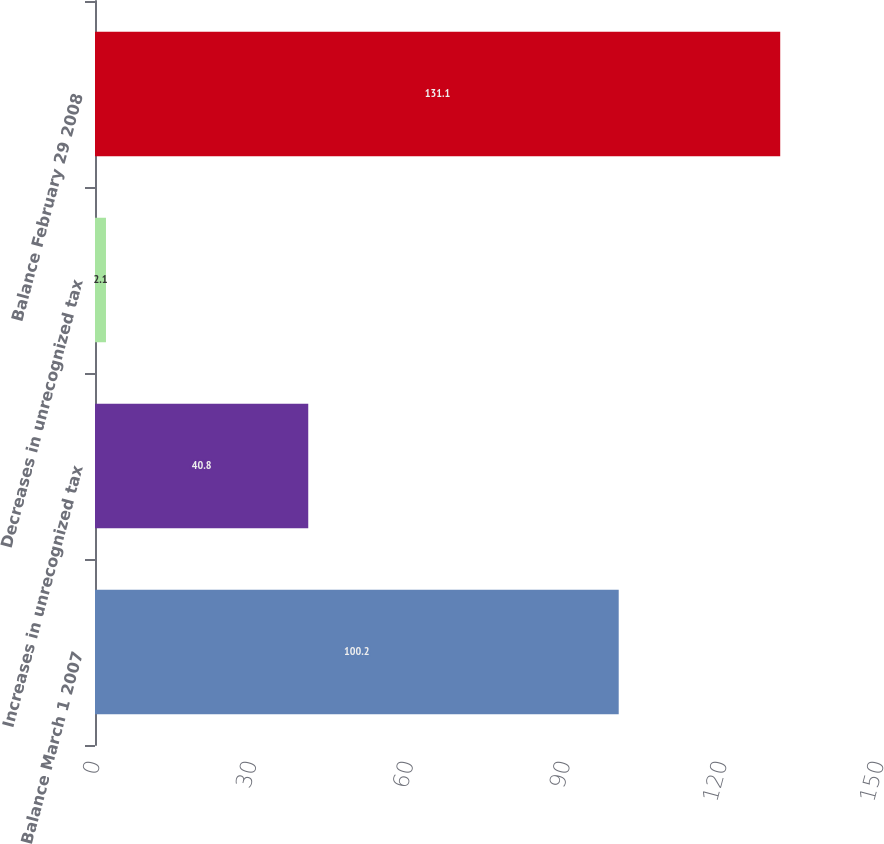Convert chart to OTSL. <chart><loc_0><loc_0><loc_500><loc_500><bar_chart><fcel>Balance March 1 2007<fcel>Increases in unrecognized tax<fcel>Decreases in unrecognized tax<fcel>Balance February 29 2008<nl><fcel>100.2<fcel>40.8<fcel>2.1<fcel>131.1<nl></chart> 